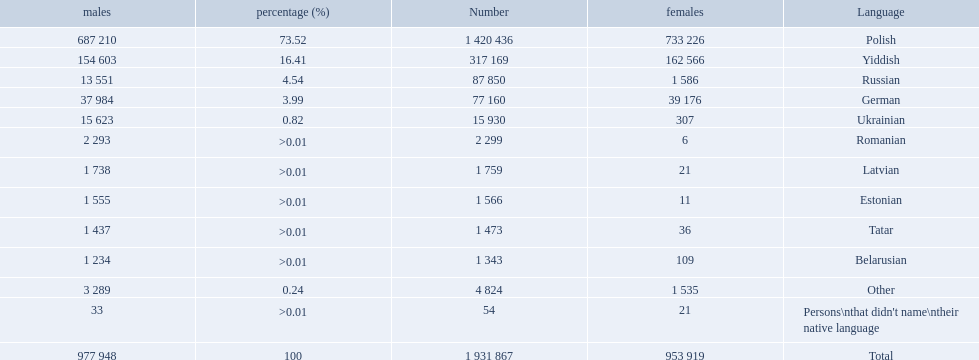What were all the languages? Polish, Yiddish, Russian, German, Ukrainian, Romanian, Latvian, Estonian, Tatar, Belarusian, Other, Persons\nthat didn't name\ntheir native language. For these, how many people spoke them? 1 420 436, 317 169, 87 850, 77 160, 15 930, 2 299, 1 759, 1 566, 1 473, 1 343, 4 824, 54. Of these, which is the largest number of speakers? 1 420 436. Which language corresponds to this number? Polish. What are all the languages? Polish, Yiddish, Russian, German, Ukrainian, Romanian, Latvian, Estonian, Tatar, Belarusian, Other, Persons\nthat didn't name\ntheir native language. Of those languages, which five had fewer than 50 females speaking it? 6, 21, 11, 36, 21. Of those five languages, which is the lowest? Romanian. How many languages are there? Polish, Yiddish, Russian, German, Ukrainian, Romanian, Latvian, Estonian, Tatar, Belarusian. Which language do more people speak? Polish. 